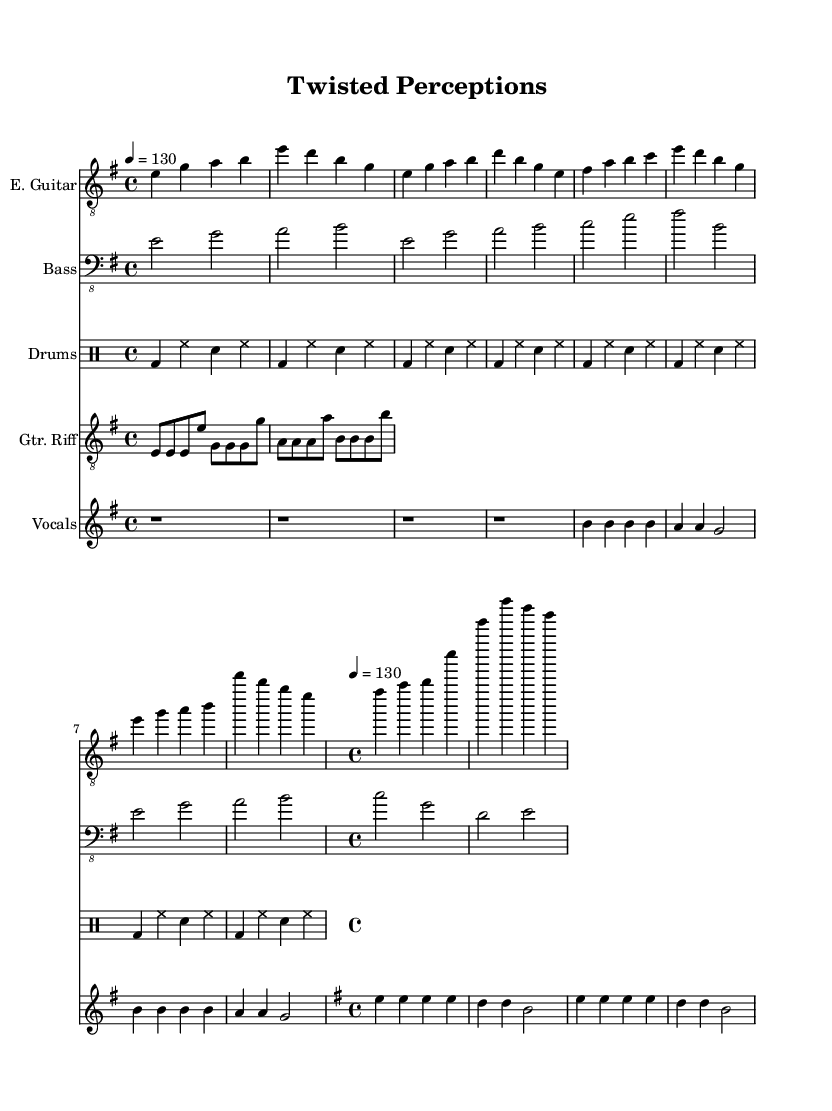What is the key signature of this music? The key signature is identified at the beginning of the sheet music, showing one sharp, which indicates that the piece is in E minor.
Answer: E minor What is the time signature of this music? The time signature is indicated at the start of the sheet music as 4/4, meaning there are four beats per measure.
Answer: 4/4 What is the tempo marking for this piece? The tempo is indicated in the score with a metronome marking of 130, suggesting a moderate pace for the performance.
Answer: 130 What instrument plays the guitar riff? The instrument playing the guitar riff is labeled as "Gtr. Riff" in the score and is positioned on the staff designated for the guitar.
Answer: E. Guitar How many measures are in the chorus section? By counting the measures explicitly within the chorus brackets, there are a total of four measures in this section of the music.
Answer: 4 What lyrical theme is suggested by the vocal line? The lyrics imply a theme of psychological struggle and perception, as suggested by phrases like "twisted perceptions" and "mind games unfold".
Answer: Psychological thrillers Which section of the music features a basic rhythm pattern on drums? The basic rhythm pattern is established in the "drumsPart" section of the score, which shows a repeating drum pattern throughout.
Answer: Drums 